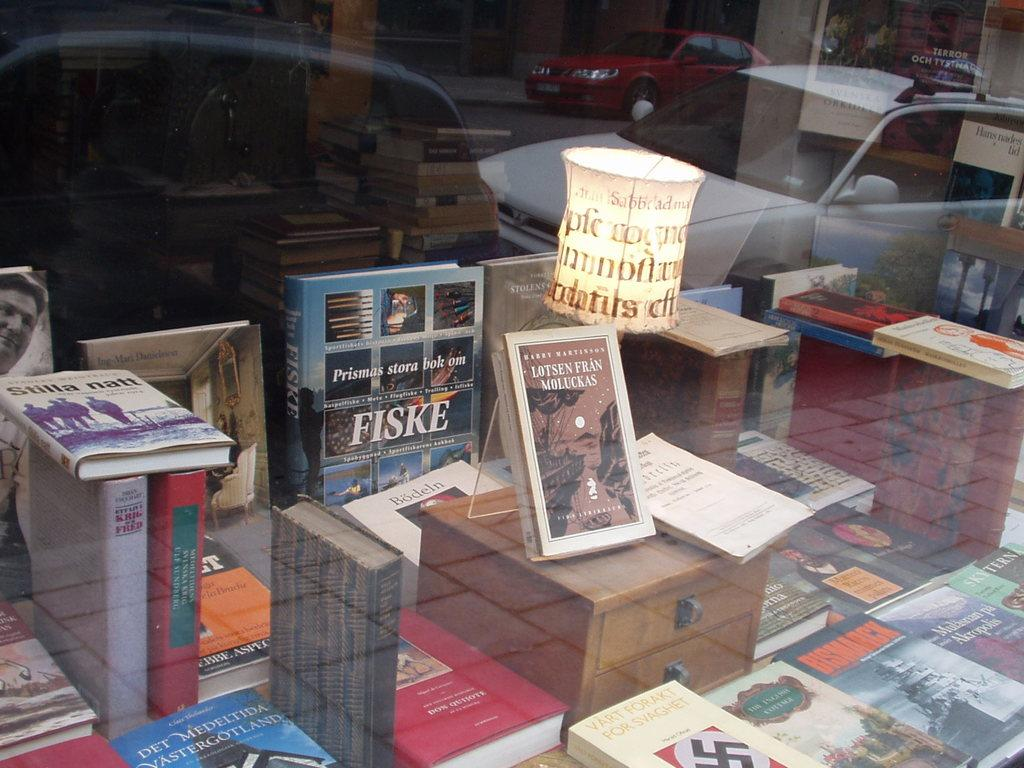What objects are on the glass platform in the image? There are books on a glass platform in the image. What can be seen through the glass platform? Cars are visible through the glass platform. Can you describe the lighting in the image? There is a light in the image. What type of quiver can be seen in the image? There is no quiver present in the image. How many trucks are visible in the image? There are no trucks visible in the image. 